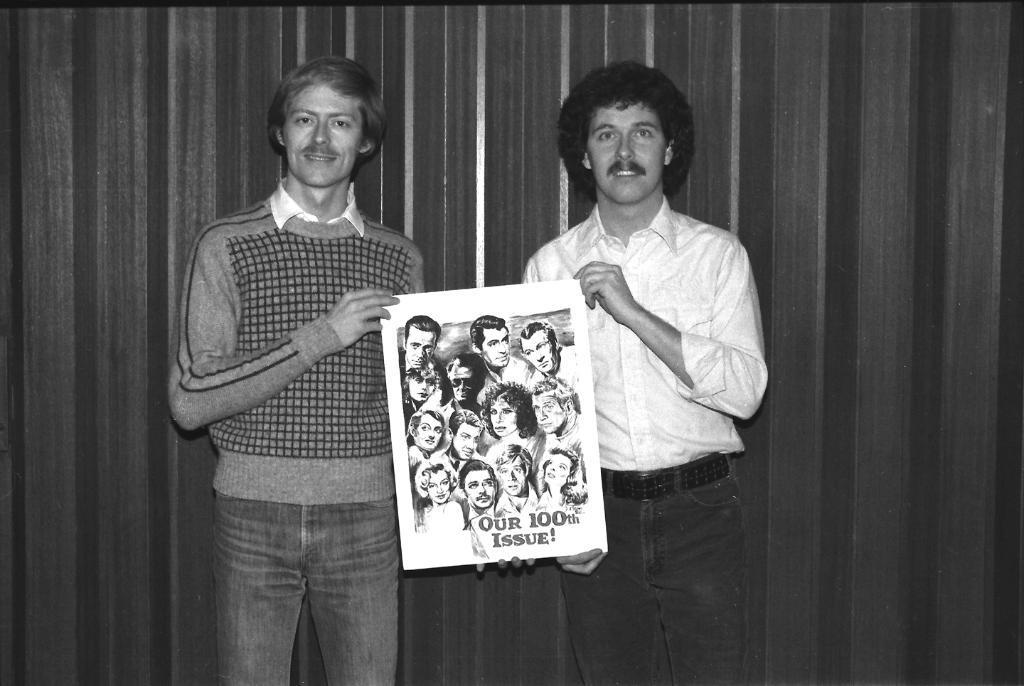Can you describe this image briefly? In the image I can see two people who are holding a poster on which there are some pictures of people and also I can see some text on it. 